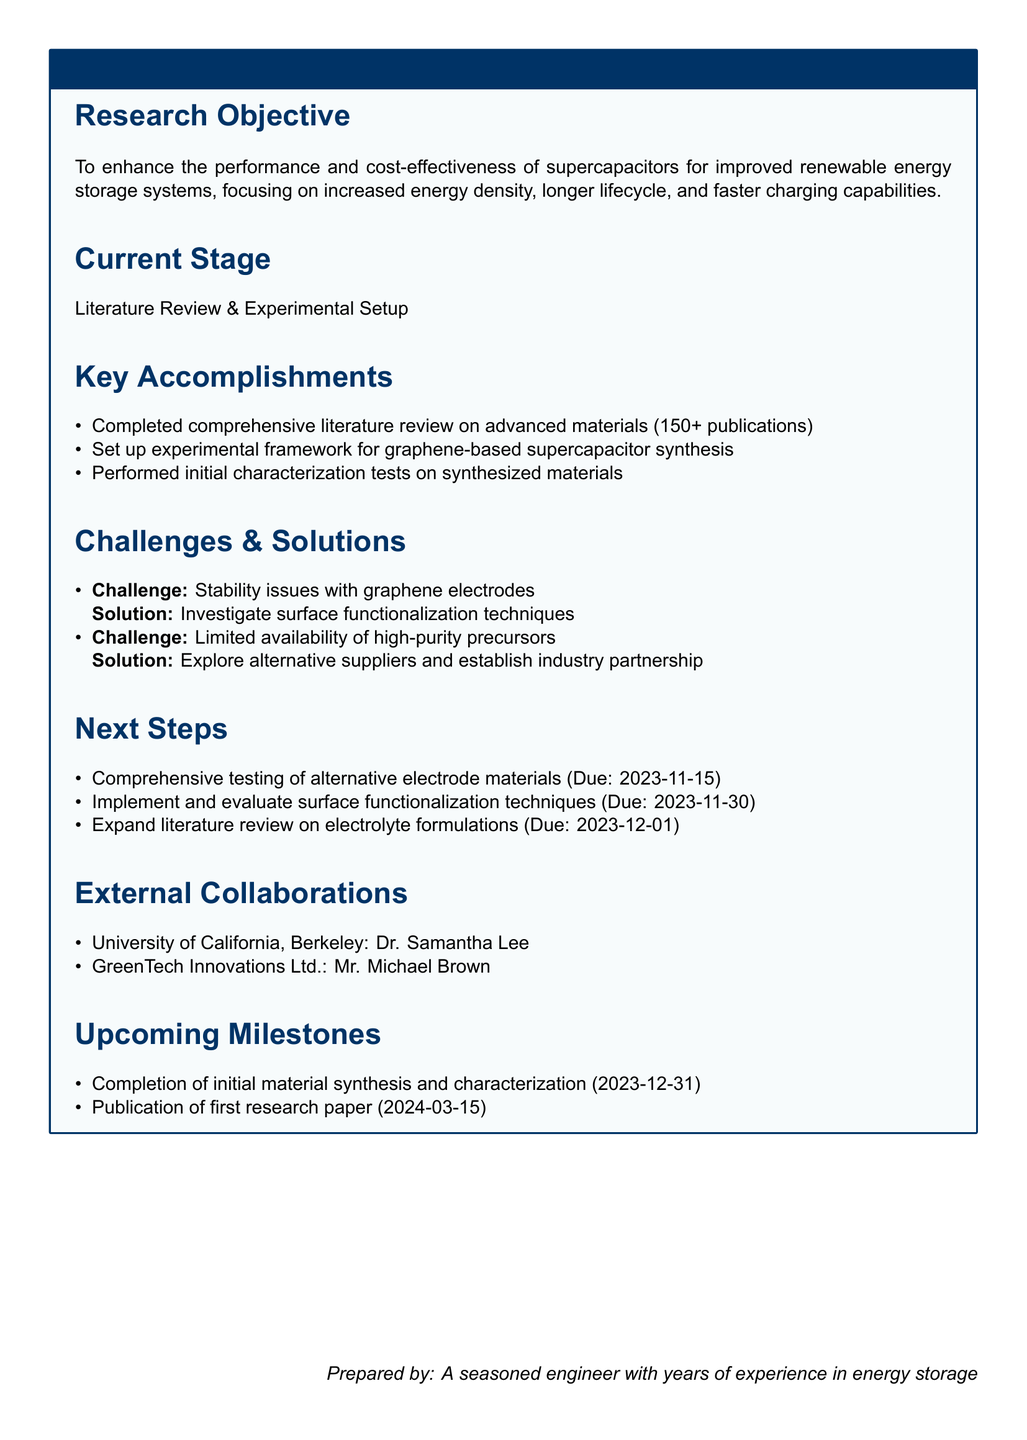What is the research objective? The research objective is to enhance the performance and cost-effectiveness of supercapacitors for improved renewable energy storage systems, focusing on increased energy density, longer lifecycle, and faster charging capabilities.
Answer: To enhance the performance and cost-effectiveness of supercapacitors for improved renewable energy storage systems, focusing on increased energy density, longer lifecycle, and faster charging capabilities What is the current stage of the research? The current stage indicates the phase of the research project outlined in the document.
Answer: Literature Review & Experimental Setup How many publications were reviewed in the literature? The number of publications completed during the literature review is explicitly stated.
Answer: 150+ What is one of the challenges faced in the research? The document lists specific challenges encountered, requiring a brief mention.
Answer: Stability issues with graphene electrodes What is the solution proposed for the challenge of limited availability of high-purity precursors? The solution is described in the challenges section and includes specific actions to address the issue.
Answer: Explore alternative suppliers and establish industry partnership When is the comprehensive testing of alternative electrode materials due? The due date for this task is specifically mentioned in the next steps section.
Answer: 2023-11-15 Who is collaborating with the research team from University of California, Berkeley? The document names individuals associated with external collaborations relevant to the research.
Answer: Dr. Samantha Lee What is the due date for the publication of the first research paper? This information is provided in the upcoming milestones section of the document.
Answer: 2024-03-15 